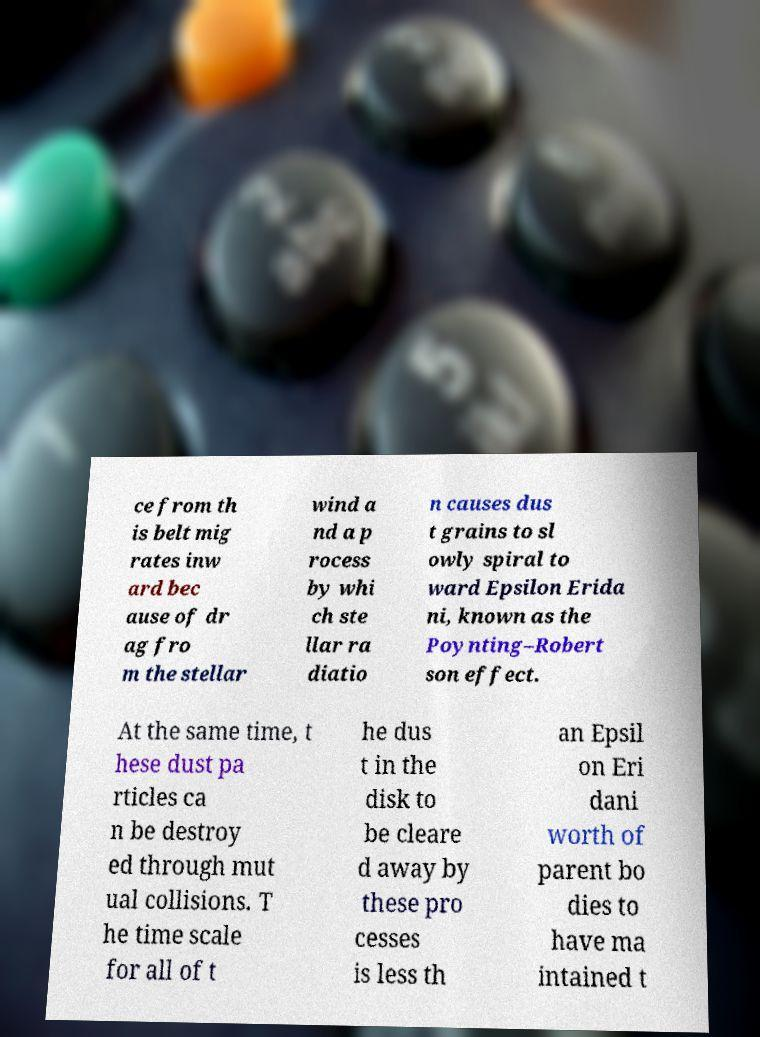I need the written content from this picture converted into text. Can you do that? ce from th is belt mig rates inw ard bec ause of dr ag fro m the stellar wind a nd a p rocess by whi ch ste llar ra diatio n causes dus t grains to sl owly spiral to ward Epsilon Erida ni, known as the Poynting–Robert son effect. At the same time, t hese dust pa rticles ca n be destroy ed through mut ual collisions. T he time scale for all of t he dus t in the disk to be cleare d away by these pro cesses is less th an Epsil on Eri dani worth of parent bo dies to have ma intained t 